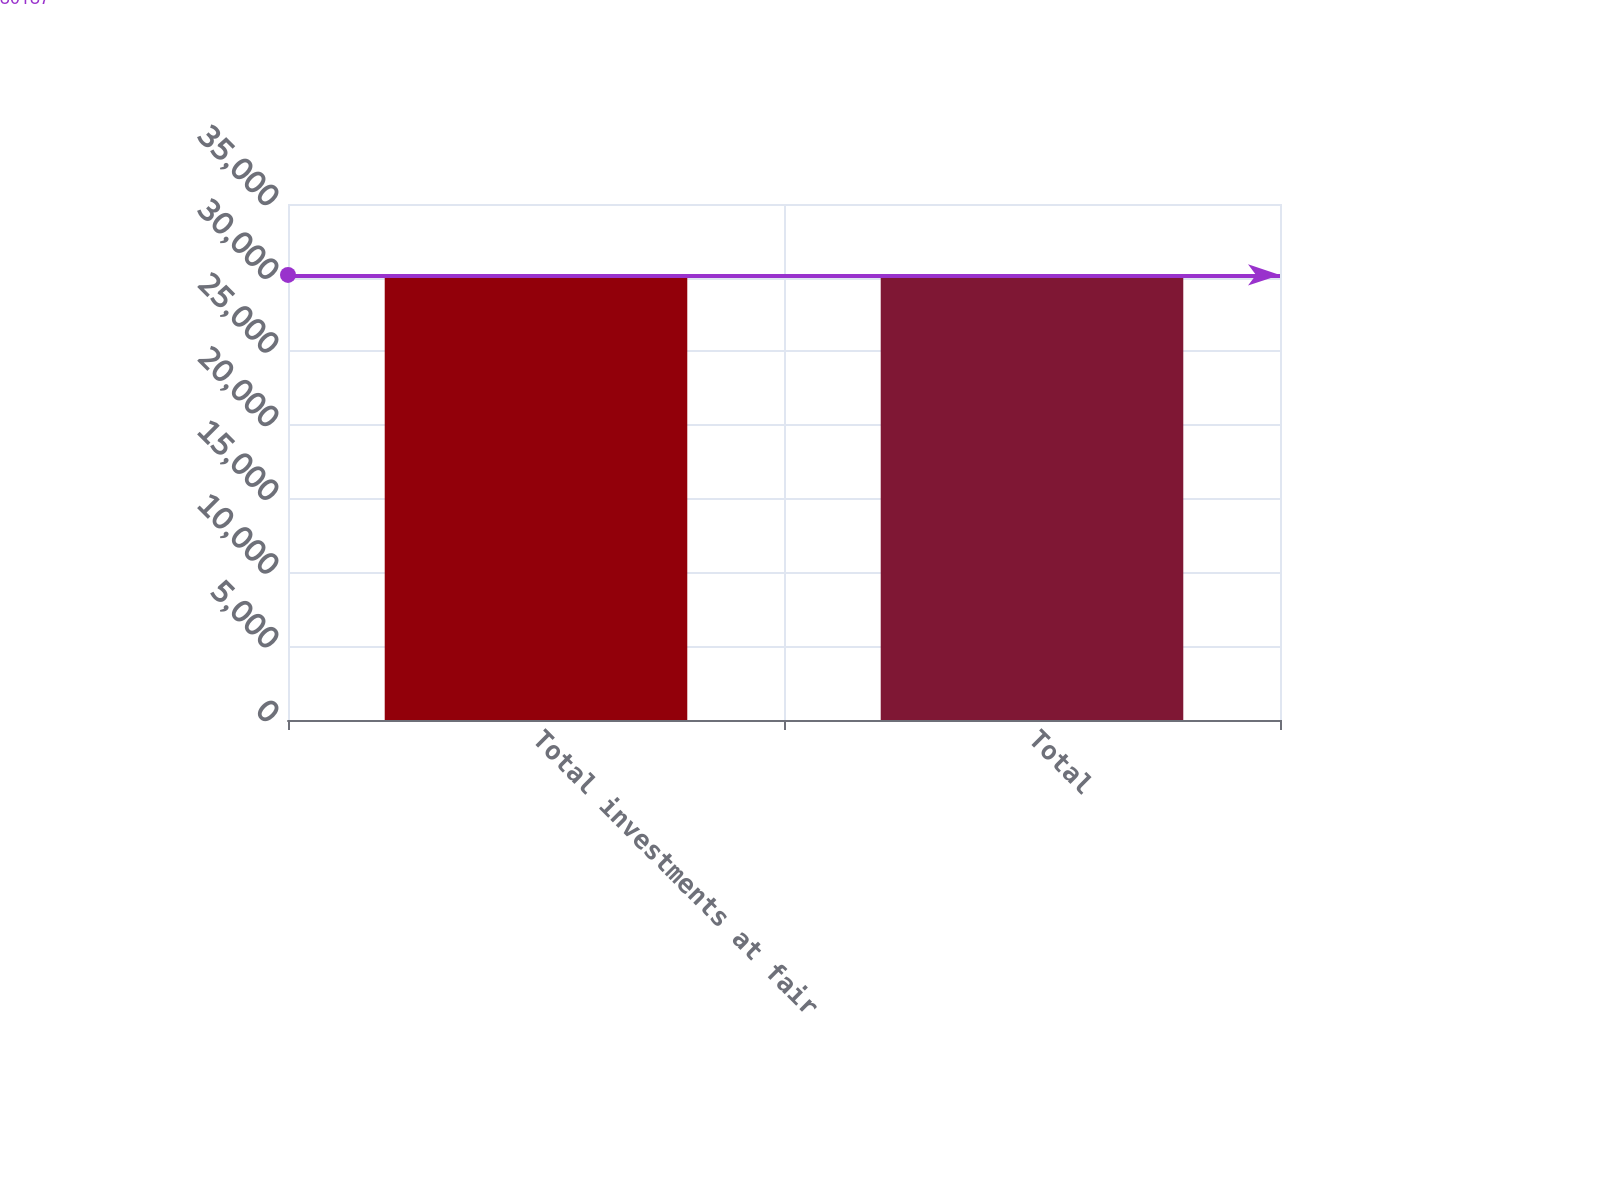Convert chart. <chart><loc_0><loc_0><loc_500><loc_500><bar_chart><fcel>Total investments at fair<fcel>Total<nl><fcel>30187<fcel>30187.1<nl></chart> 